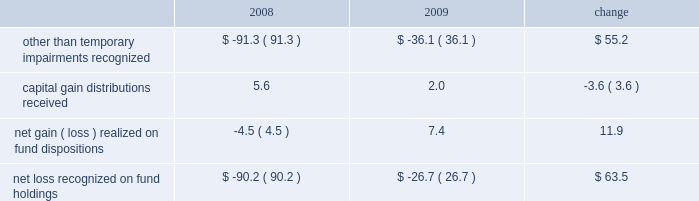Our non-operating investment activity resulted in net losses of $ 12.7 million in 2009 and $ 52.3 million in 2008 .
The improvement of nearly $ 40 million is primarily attributable to a reduction in the other than temporary impairments recognized on our investments in sponsored mutual funds in 2009 versus 2008 .
The table details our related mutual fund investment gains and losses ( in millions ) during the past two years. .
Lower income of $ 16 million from our money market holdings due to the significantly lower interest rate environment offset the improvement experienced with our fund investments .
There is no impairment of any of our mutual fund investments at december 31 , 2009 .
The 2009 provision for income taxes as a percentage of pretax income is 37.1% ( 37.1 % ) , down from 38.4% ( 38.4 % ) in 2008 and .9% ( .9 % ) lower than our present estimate of 38.0% ( 38.0 % ) for the 2010 effective tax rate .
Our 2009 provision includes reductions of prior years 2019 tax provisions and discrete nonrecurring benefits that lowered our 2009 effective tax rate by 1.0% ( 1.0 % ) .
2008 versus 2007 .
Investment advisory revenues decreased 6.3% ( 6.3 % ) , or $ 118 million , to $ 1.76 billion in 2008 as average assets under our management decreased $ 16 billion to $ 358.2 billion .
The average annualized fee rate earned on our assets under management was 49.2 basis points in 2008 , down from the 50.2 basis points earned in 2007 , as lower equity market valuations resulted in a greater percentage of our assets under management being attributable to lower fee fixed income portfolios .
Continuing stress on the financial markets and resulting lower equity valuations as 2008 progressed resulted in lower average assets under our management , lower investment advisory fees and lower net income as compared to prior periods .
Net revenues decreased 5% ( 5 % ) , or $ 112 million , to $ 2.12 billion .
Operating expenses were $ 1.27 billion in 2008 , up 2.9% ( 2.9 % ) or $ 36 million from 2007 .
Net operating income for 2008 decreased $ 147.9 million , or 14.8% ( 14.8 % ) , to $ 848.5 million .
Higher operating expenses in 2008 and decreased market valuations during the latter half of 2008 , which lowered our assets under management and advisory revenues , resulted in our 2008 operating margin declining to 40.1% ( 40.1 % ) from 44.7% ( 44.7 % ) in 2007 .
Non-operating investment losses in 2008 were $ 52.3 million as compared to investment income of $ 80.4 million in 2007 .
Investment losses in 2008 include non-cash charges of $ 91.3 million for the other than temporary impairment of certain of the firm 2019s investments in sponsored mutual funds .
Net income in 2008 fell 27% ( 27 % ) or nearly $ 180 million from 2007 .
Diluted earnings per share , after the retrospective application of new accounting guidance effective in 2009 , decreased to $ 1.81 , down $ .59 or 24.6% ( 24.6 % ) from $ 2.40 in 2007 .
A non-operating charge to recognize other than temporary impairments of our sponsored mutual fund investments reduced diluted earnings per share by $ .21 in 2008 .
Investment advisory revenues earned from the t .
Rowe price mutual funds distributed in the united states decreased 8.5% ( 8.5 % ) , or $ 114.5 million , to $ 1.24 billion .
Average mutual fund assets were $ 216.1 billion in 2008 , down $ 16.7 billion from 2007 .
Mutual fund assets at december 31 , 2008 , were $ 164.4 billion , down $ 81.6 billion from the end of 2007 .
Net inflows to the mutual funds during 2008 were $ 3.9 billion , including $ 1.9 billion to the money funds , $ 1.1 billion to the bond funds , and $ .9 billion to the stock funds .
The value , equity index 500 , and emerging markets stock funds combined to add $ 4.1 billion , while the mid-cap growth and equity income stock funds had net redemptions of $ 2.2 billion .
Net fund inflows of $ 6.2 billion originated in our target-date retirement funds , which in turn invest in other t .
Rowe price funds .
Fund net inflow amounts in 2008 are presented net of $ 1.3 billion that was transferred to target-date trusts from the retirement funds during the year .
Decreases in market valuations and income not reinvested lowered our mutual fund assets under management by $ 85.5 billion during 2008 .
Investment advisory revenues earned on the other investment portfolios that we manage decreased $ 3.6 million to $ 522.2 million .
Average assets in these portfolios were $ 142.1 billion during 2008 , up slightly from $ 141.4 billion in 2007 .
These minor changes , each less than 1% ( 1 % ) , are attributable to the timing of declining equity market valuations and cash flows among our separate account and subadvised portfolios .
Net inflows , primarily from institutional investors , were $ 13.2 billion during 2008 , including the $ 1.3 billion transferred from the retirement funds to target-date trusts .
Decreases in market valuations , net of income , lowered our assets under management in these portfolios by $ 55.3 billion during 2008 .
Management 2019s discussion & analysis 21 .
How much were investment advisory revenues in 2007 , in millions of dollars? 
Rationale: "investment advisory revenues decreased 6.3% , or $ 118 million , to $ 1.76 billion in 2008" implies the value from 2007
Computations: ((1.76 * 1000) + 118)
Answer: 1878.0. 